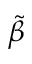<formula> <loc_0><loc_0><loc_500><loc_500>\tilde { \beta }</formula> 